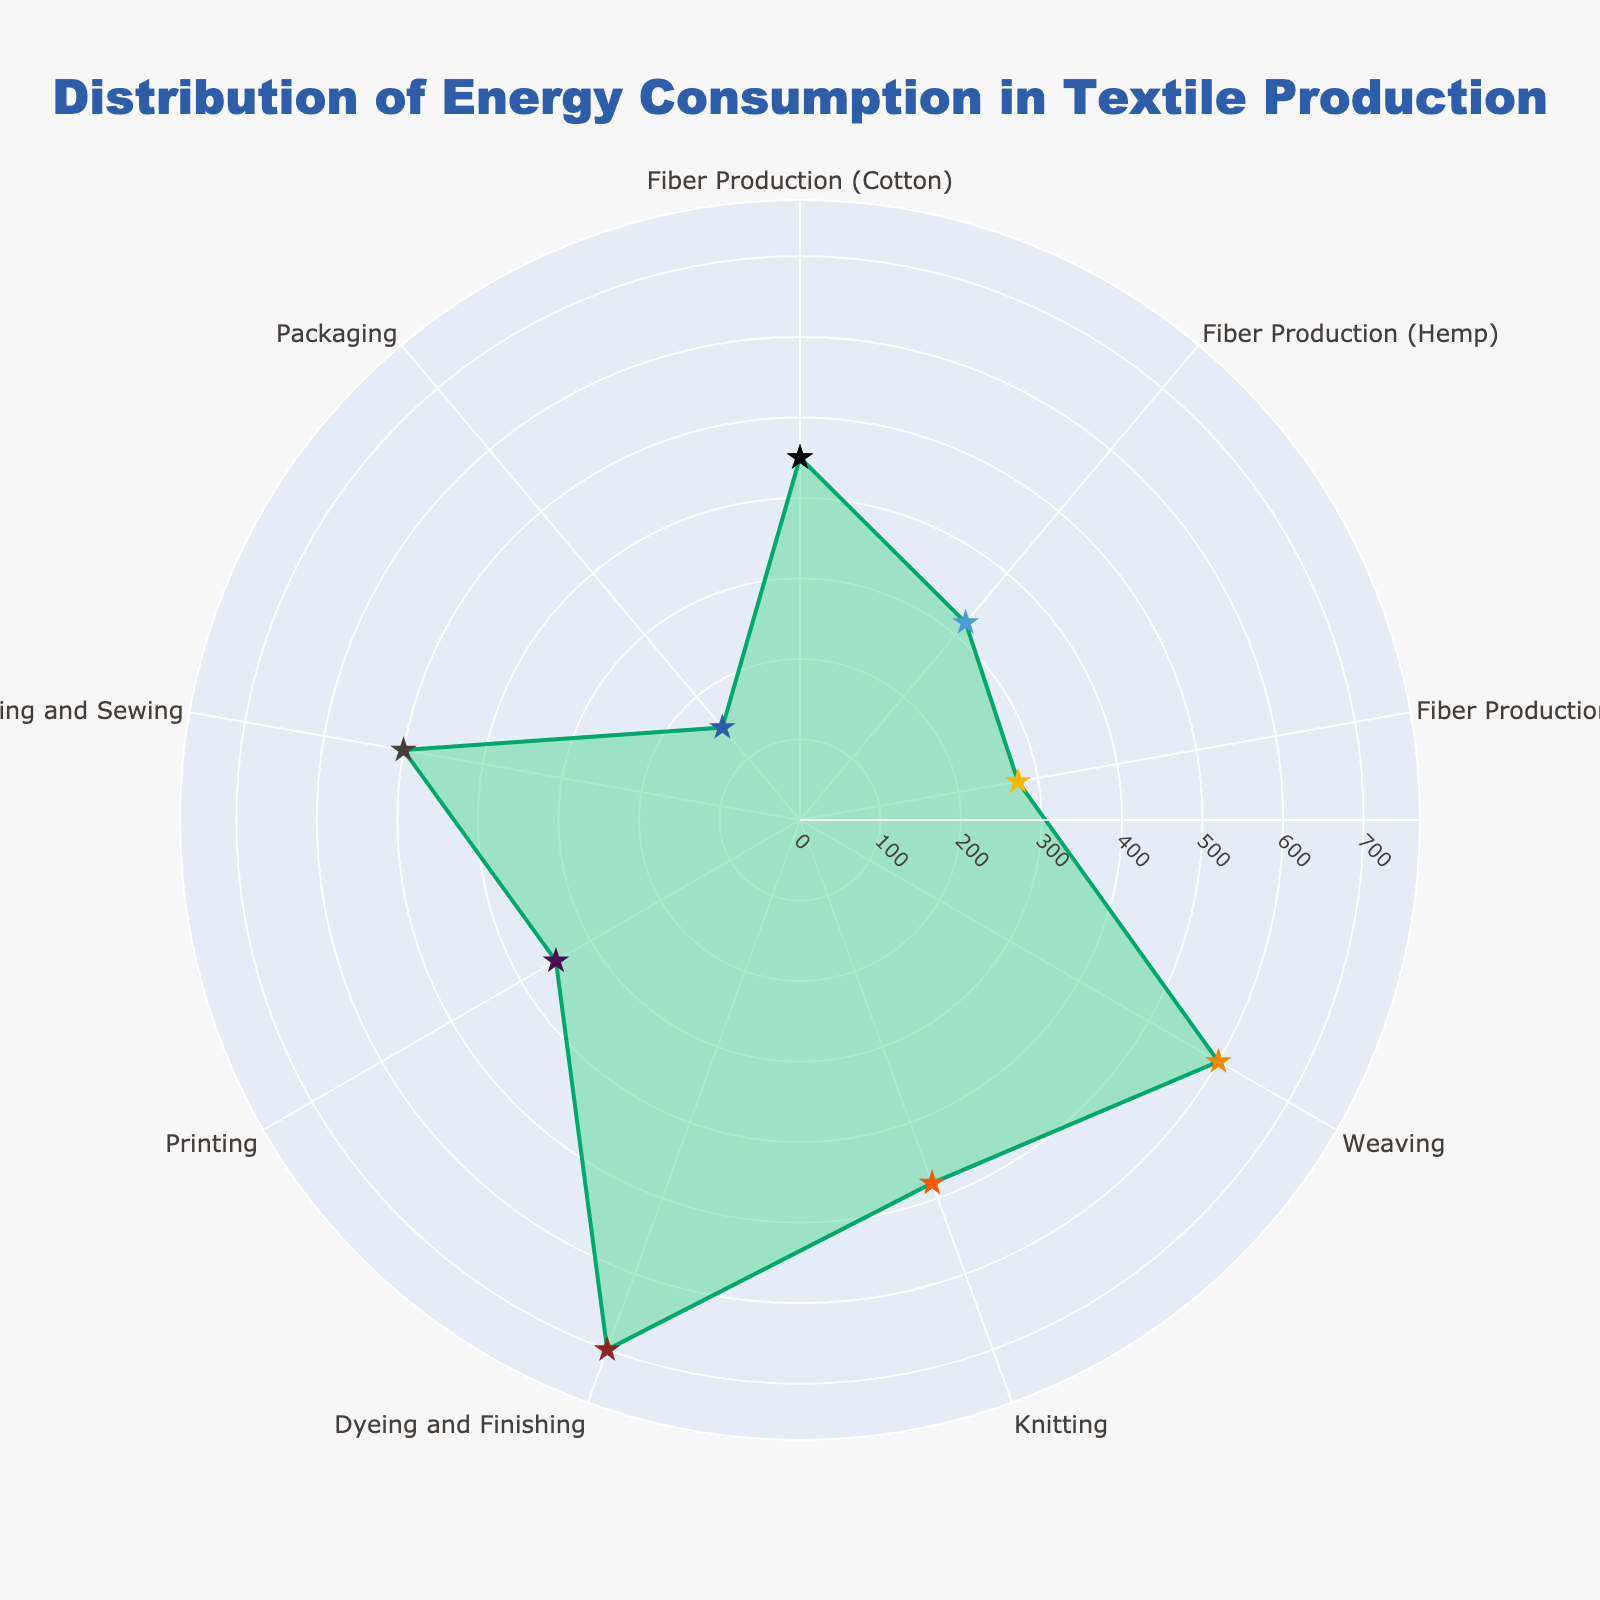What's the title of this figure? The title is prominently displayed at the top of the figure in a large font.
Answer: Distribution of Energy Consumption in Textile Production What is the energy consumption for dyeing and finishing? By hovering over the section corresponding to Dyeing and Finishing, we can see the energy consumption value.
Answer: 700 kWh Which category has the highest energy consumption? By comparing the lengths of the segments, the largest segment corresponds to the category with the highest energy consumption.
Answer: Dyeing and Finishing What is the total energy consumption for fiber production (all types combined)? Add the energy consumption values for Fiber Production (Cotton), Fiber Production (Hemp), and Fiber Production (Recycled PET). (450 + 320 + 275) kWh.
Answer: 1045 kWh How does the energy consumption for packaging compare to that for printing? Compare the energy consumption values for Packaging and Printing, specifically looking at the lengths of the corresponding segments. Packaging (150 kWh) is less than Printing (350 kWh).
Answer: Packaging is less Which category has the lowest energy consumption? Identify the smallest segment on the chart, which corresponds to the category with the lowest energy consumption.
Answer: Packaging What is the average energy consumption across all categories? Sum all the energy consumption values and divide by the number of categories. Total energy consumption is 3825 kWh, with 9 categories: 3825 / 9 kWh.
Answer: 425 kWh What is the difference in energy consumption between weaving and knitting? Subtract the energy consumption of Knitting from that of Weaving: Weaving (600 kWh) - Knitting (480 kWh).
Answer: 120 kWh How much more energy does dyeing and finishing consume compared to fiber production (Hemp)? Subtract the energy consumption of Fiber Production (Hemp) from that of Dyeing and Finishing: Dyeing and Finishing (700 kWh) - Fiber Production (Hemp) (320 kWh).
Answer: 380 kWh Between weaving, knitting, and cutting and sewing, which category has the highest energy consumption? Compare the energy consumption values for Weaving, Knitting, and Cutting and Sewing, and identify the highest one. Weaving (600 kWh), Knitting (480 kWh), Cutting and Sewing (500 kWh).
Answer: Weaving 